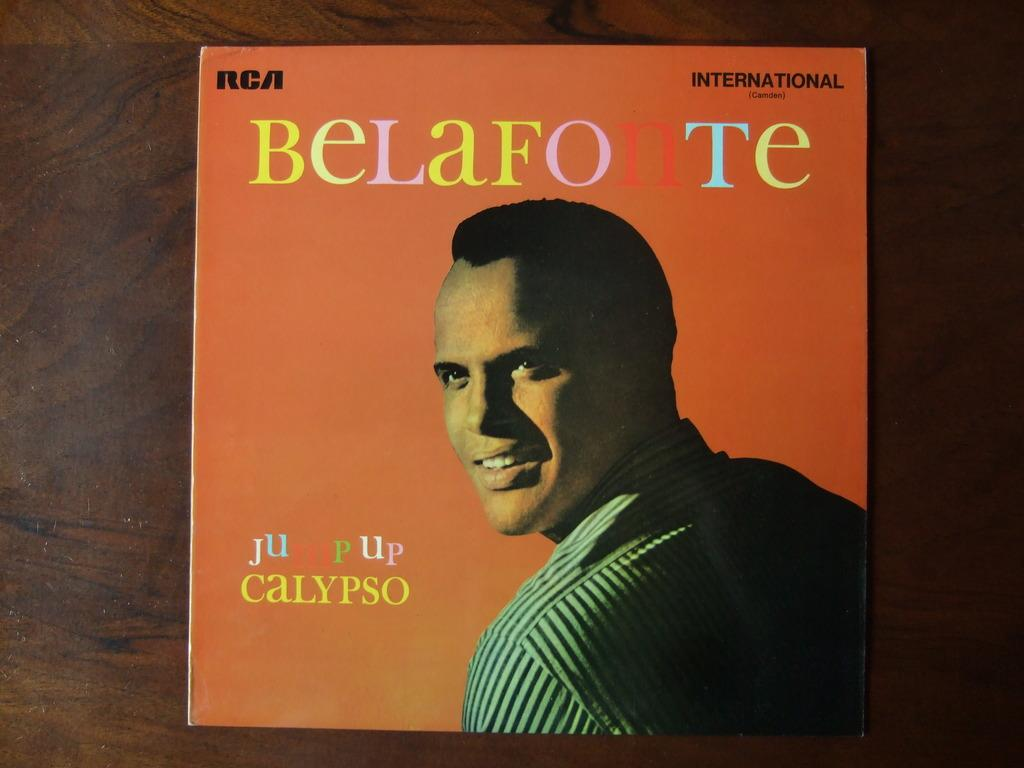What is present on the wooden surface in the image? There is a poster on the wooden surface. Can you describe the poster? The poster has a person depicted on it and also includes text. What type of garden can be seen in the image? There is no garden present in the image; it features a poster on a wooden surface. What offer is being made by the person depicted on the poster? There is no offer being made by the person depicted on the poster, as the image only shows the poster itself and does not provide any context for the person's actions or intentions. 